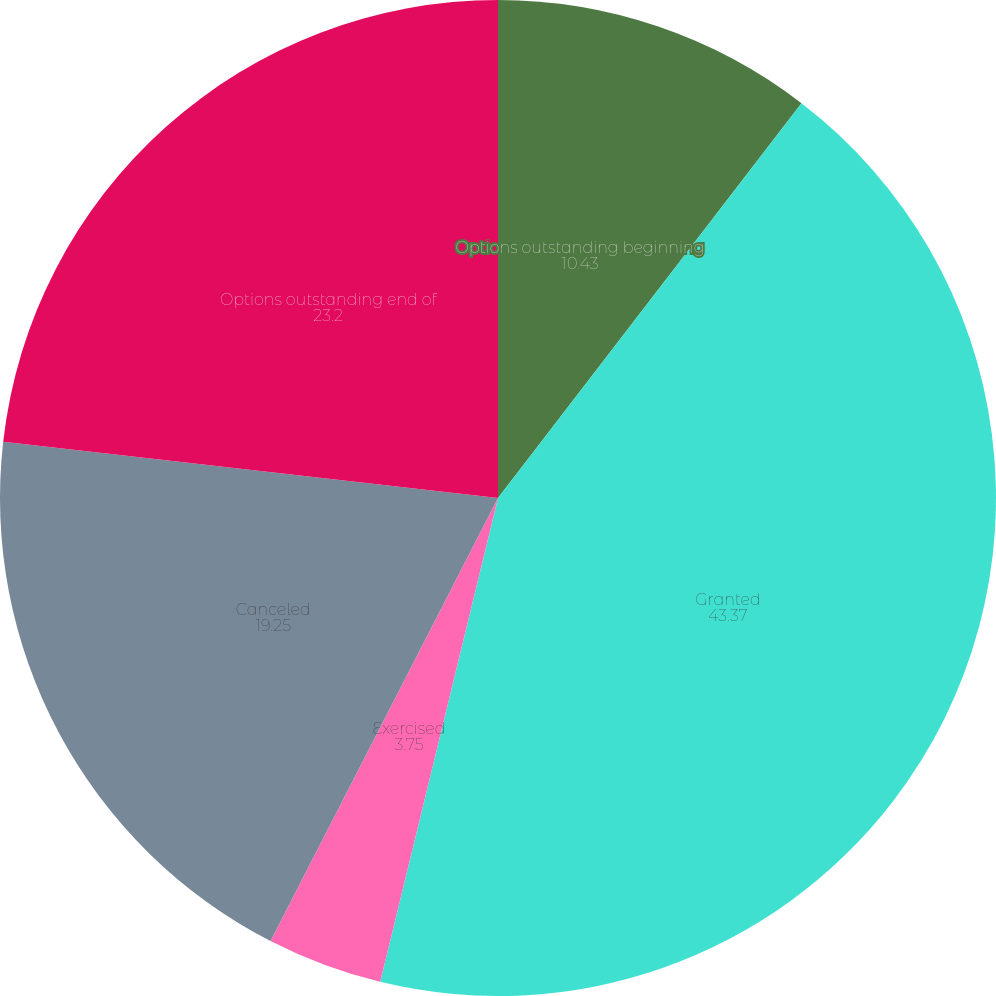Convert chart to OTSL. <chart><loc_0><loc_0><loc_500><loc_500><pie_chart><fcel>Options outstanding beginning<fcel>Granted<fcel>Exercised<fcel>Canceled<fcel>Options outstanding end of<nl><fcel>10.43%<fcel>43.37%<fcel>3.75%<fcel>19.25%<fcel>23.2%<nl></chart> 